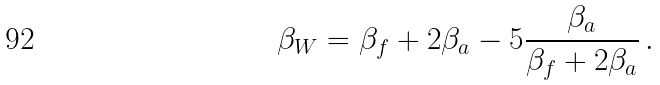Convert formula to latex. <formula><loc_0><loc_0><loc_500><loc_500>\beta _ { W } = \beta _ { f } + 2 \beta _ { a } - 5 \frac { \beta _ { a } } { \beta _ { f } + 2 \beta _ { a } } \, .</formula> 